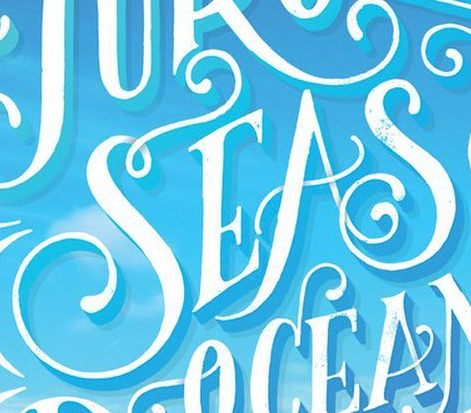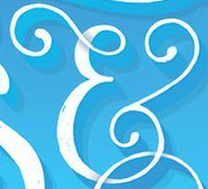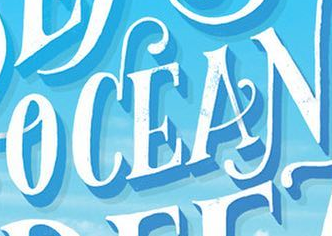What text appears in these images from left to right, separated by a semicolon? SEAS; &; OCEAN 